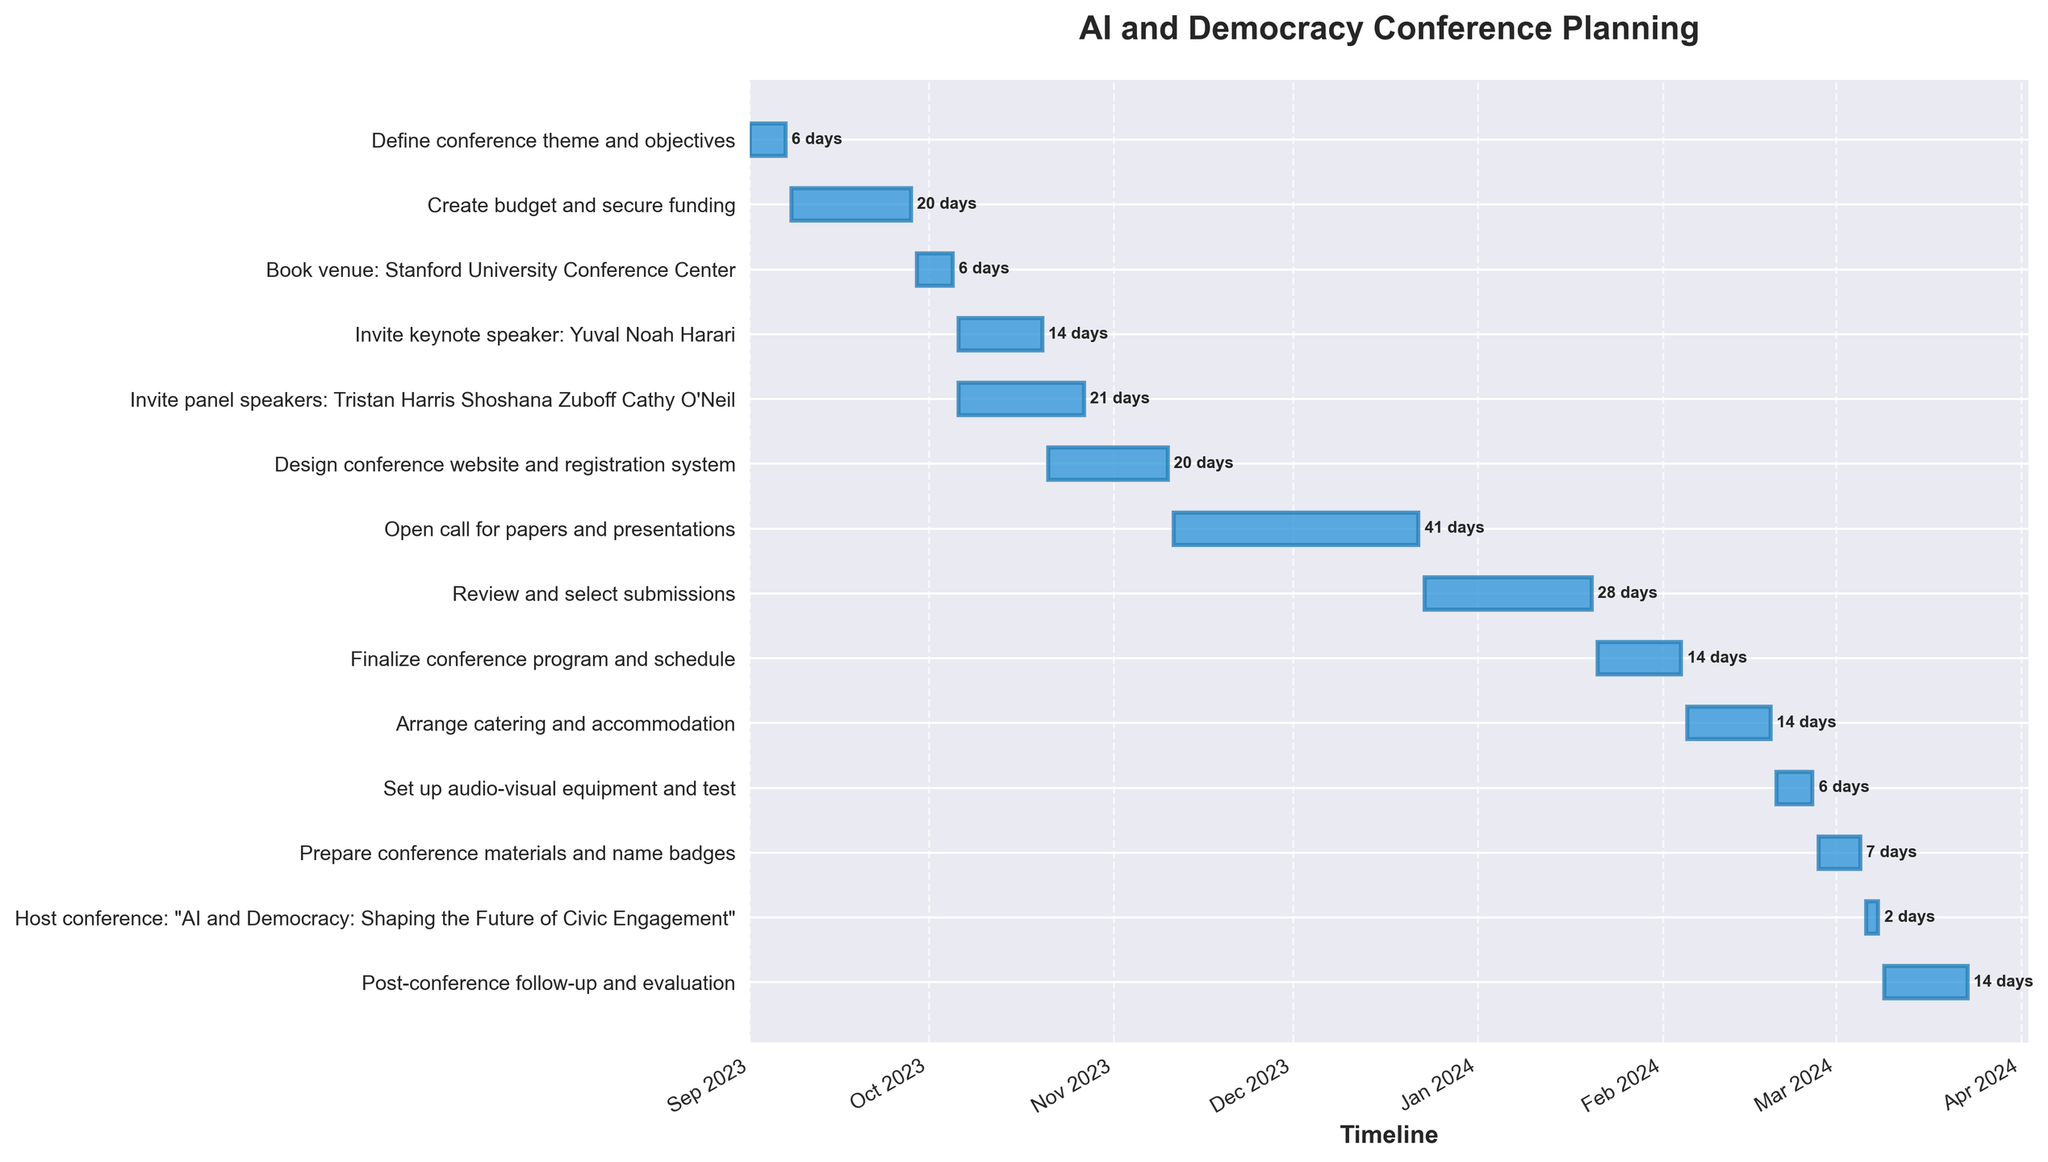How long does it take to review and select submissions? Locate the bar corresponding to "Review and select submissions" and note its duration.
Answer: 29 days When is the conference "AI and Democracy: Shaping the Future of Civic Engagement" being hosted? Find the bar labeled "Host conference" and check its start and end dates. It starts on 2024-03-06 and ends on 2024-03-08.
Answer: 2024-03-06 to 2024-03-08 Which task has the shortest duration, and how many days is it? Visually inspect the lengths of the bars and note the shortest one. The shortest task is "Host conference", which lasts for 3 days.
Answer: Host conference, 3 days What is the total duration of the tasks before the conference starts? Add up the durations of all tasks that end before 2024-03-06. This includes defining the theme (7 days), creating the budget (21 days), booking the venue (7 days), inviting speakers (15 and 22 days), designing the website (21 days), opening calls for papers (42 days), reviewing submissions (29 days), finalizing the program (15 days), arranging catering (15 days), setting up AV equipment (7 days), and preparing materials (8 days).
Answer: 209 days What is the relationship between the start dates of "Invite keynote speaker: Yuval Noah Harari" and "Invite panel speakers: Tristan Harris, Shoshana Zuboff, Cathy O'Neil"? Compare the start dates of both tasks, which are visually aligned with a common start.
Answer: Both tasks start on the same day, 2023-10-06 How much longer is the "Invite panel speakers" task compared to "Invite keynote speaker"? Subtract the duration of "Invite keynote speaker" (15 days) from "Invite panel speakers" (22 days).
Answer: 7 days longer Which task directly follows the completion of the "Design conference website and registration system"? Look for the task that starts right after "Design conference website and registration system" ends on 2023-11-10. The next task starts on 2023-11-11, which is "Open call for papers and presentations".
Answer: Open call for papers and presentations On which date does the "Finalize conference program and schedule" task begin? Find the task "Finalize conference program and schedule" and check its start date, which is shown on the Gantt chart.
Answer: 2024-01-21 Which task requires the longest preparation time, and how many days does it take? Review the durations of all tasks and identify that "Open call for papers and presentations" is the longest, lasting 42 days.
Answer: Open call for papers and presentations, 42 days What is the sequence of tasks from setting up audio-visual equipment to the post-conference follow-up? Identify tasks in order: Set up audio-visual equipment (2024-02-20 to 2024-02-26), Prepare conference materials (2024-02-27 to 2024-03-05), Host conference (2024-03-06 to 2024-03-08), Post-conference follow-up (2024-03-09 to 2024-03-23).
Answer: Set up audio-visual equipment, Prepare conference materials and name badges, Host conference, Post-conference follow-up and evaluation 